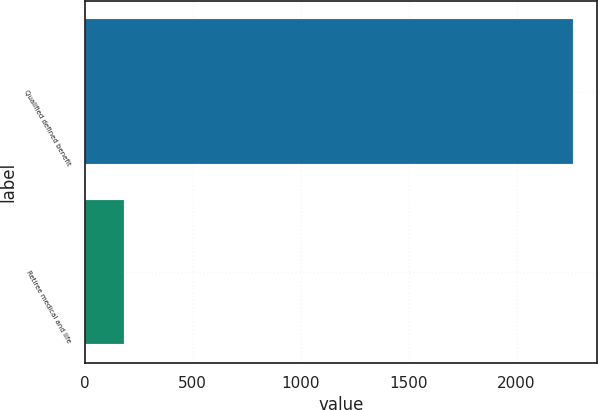Convert chart. <chart><loc_0><loc_0><loc_500><loc_500><bar_chart><fcel>Qualified defined benefit<fcel>Retiree medical and life<nl><fcel>2260<fcel>180<nl></chart> 